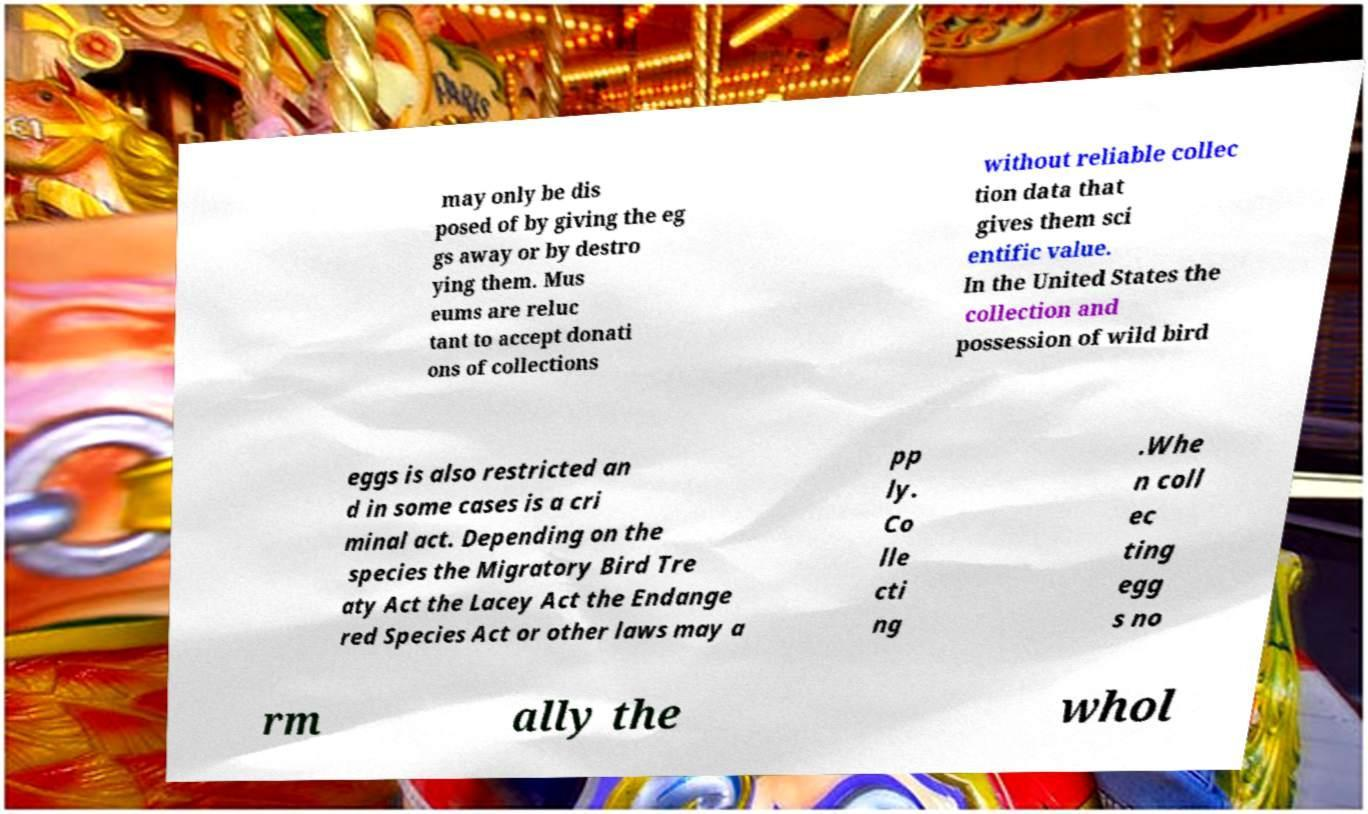Could you assist in decoding the text presented in this image and type it out clearly? may only be dis posed of by giving the eg gs away or by destro ying them. Mus eums are reluc tant to accept donati ons of collections without reliable collec tion data that gives them sci entific value. In the United States the collection and possession of wild bird eggs is also restricted an d in some cases is a cri minal act. Depending on the species the Migratory Bird Tre aty Act the Lacey Act the Endange red Species Act or other laws may a pp ly. Co lle cti ng .Whe n coll ec ting egg s no rm ally the whol 